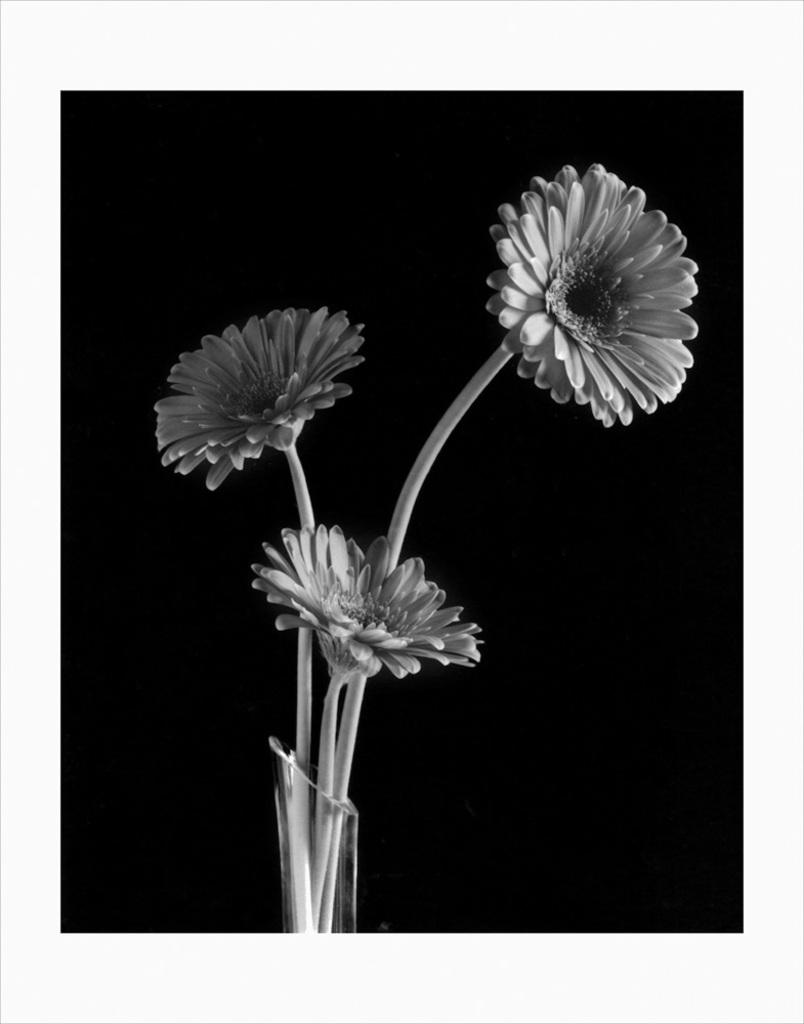What color are the borders of the image? The image has white borders. What can be found inside the jar in the image? There are flowers in a jar in the image. What color is the background of the image? The background of the image is black. Can you see a snake slithering in the background of the image? There is no snake present in the image; the background is black. 